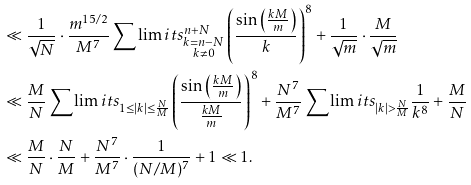<formula> <loc_0><loc_0><loc_500><loc_500>& \ll \frac { 1 } { \sqrt { N } } \cdot \frac { m ^ { 1 5 / 2 } } { M ^ { 7 } } \sum \lim i t s _ { \substack { k = n - N \\ k \ne 0 } } ^ { n + N } \left ( \frac { \sin \left ( \frac { k M } { m } \right ) } { k } \right ) ^ { 8 } + \frac { 1 } { \sqrt { m } } \cdot \frac { M } { \sqrt { m } } \\ & \ll \frac { M } { N } \sum \lim i t s _ { 1 \leq | k | \leq \frac { N } { M } } \left ( \frac { \sin \left ( \frac { k M } { m } \right ) } { \frac { k M } { m } } \right ) ^ { 8 } + \frac { N ^ { 7 } } { M ^ { 7 } } \sum \lim i t s _ { | k | > \frac { N } { M } } \frac { 1 } { k ^ { 8 } } + \frac { M } { N } \\ & \ll \frac { M } { N } \cdot \frac { N } { M } + \frac { N ^ { 7 } } { M ^ { 7 } } \cdot \frac { 1 } { ( N / M ) ^ { 7 } } + 1 \ll 1 .</formula> 